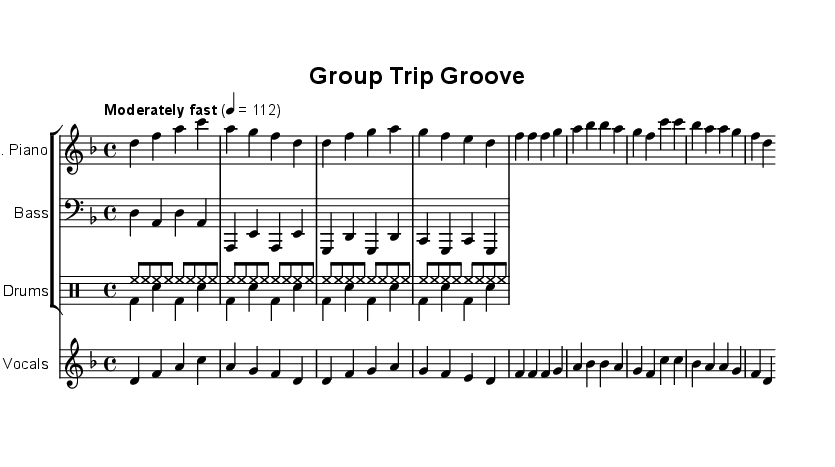What is the key signature of this music? The key signature is D minor, indicated by one flat (B flat).
Answer: D minor What is the time signature of this music? The time signature is 4/4, as seen at the beginning of the score.
Answer: 4/4 What tempo marking is indicated in the score? The tempo marking is "Moderately fast" with a specific metronome marking of quarter note = 112.
Answer: Moderately fast How many measures are in the verse melody? The verse melody contains four measures, as it is indicated by the notation.
Answer: Four What instrument plays the melody in this piece? The melody is played by the electric piano, which is labeled in the staff.
Answer: Electric Piano What is the main theme of the lyrics in this song? The main theme of the lyrics revolves around planning group excursions and the excitement of traveling together, as articulated in the verses and choruses.
Answer: Group excursions What genre does this music belong to? The music belongs to the Rhythm and Blues genre, which is characterized by its soulful melodies and rhythmic style.
Answer: Rhythm and Blues 